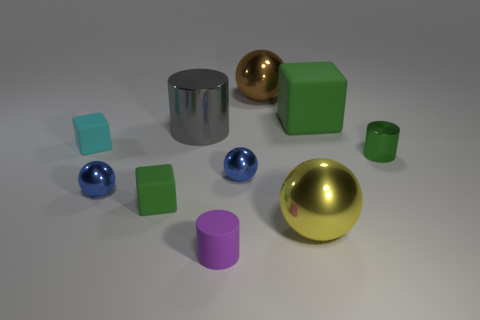Subtract all cylinders. How many objects are left? 7 Add 3 blue objects. How many blue objects exist? 5 Subtract 0 blue cylinders. How many objects are left? 10 Subtract all green matte objects. Subtract all blue shiny blocks. How many objects are left? 8 Add 5 brown shiny spheres. How many brown shiny spheres are left? 6 